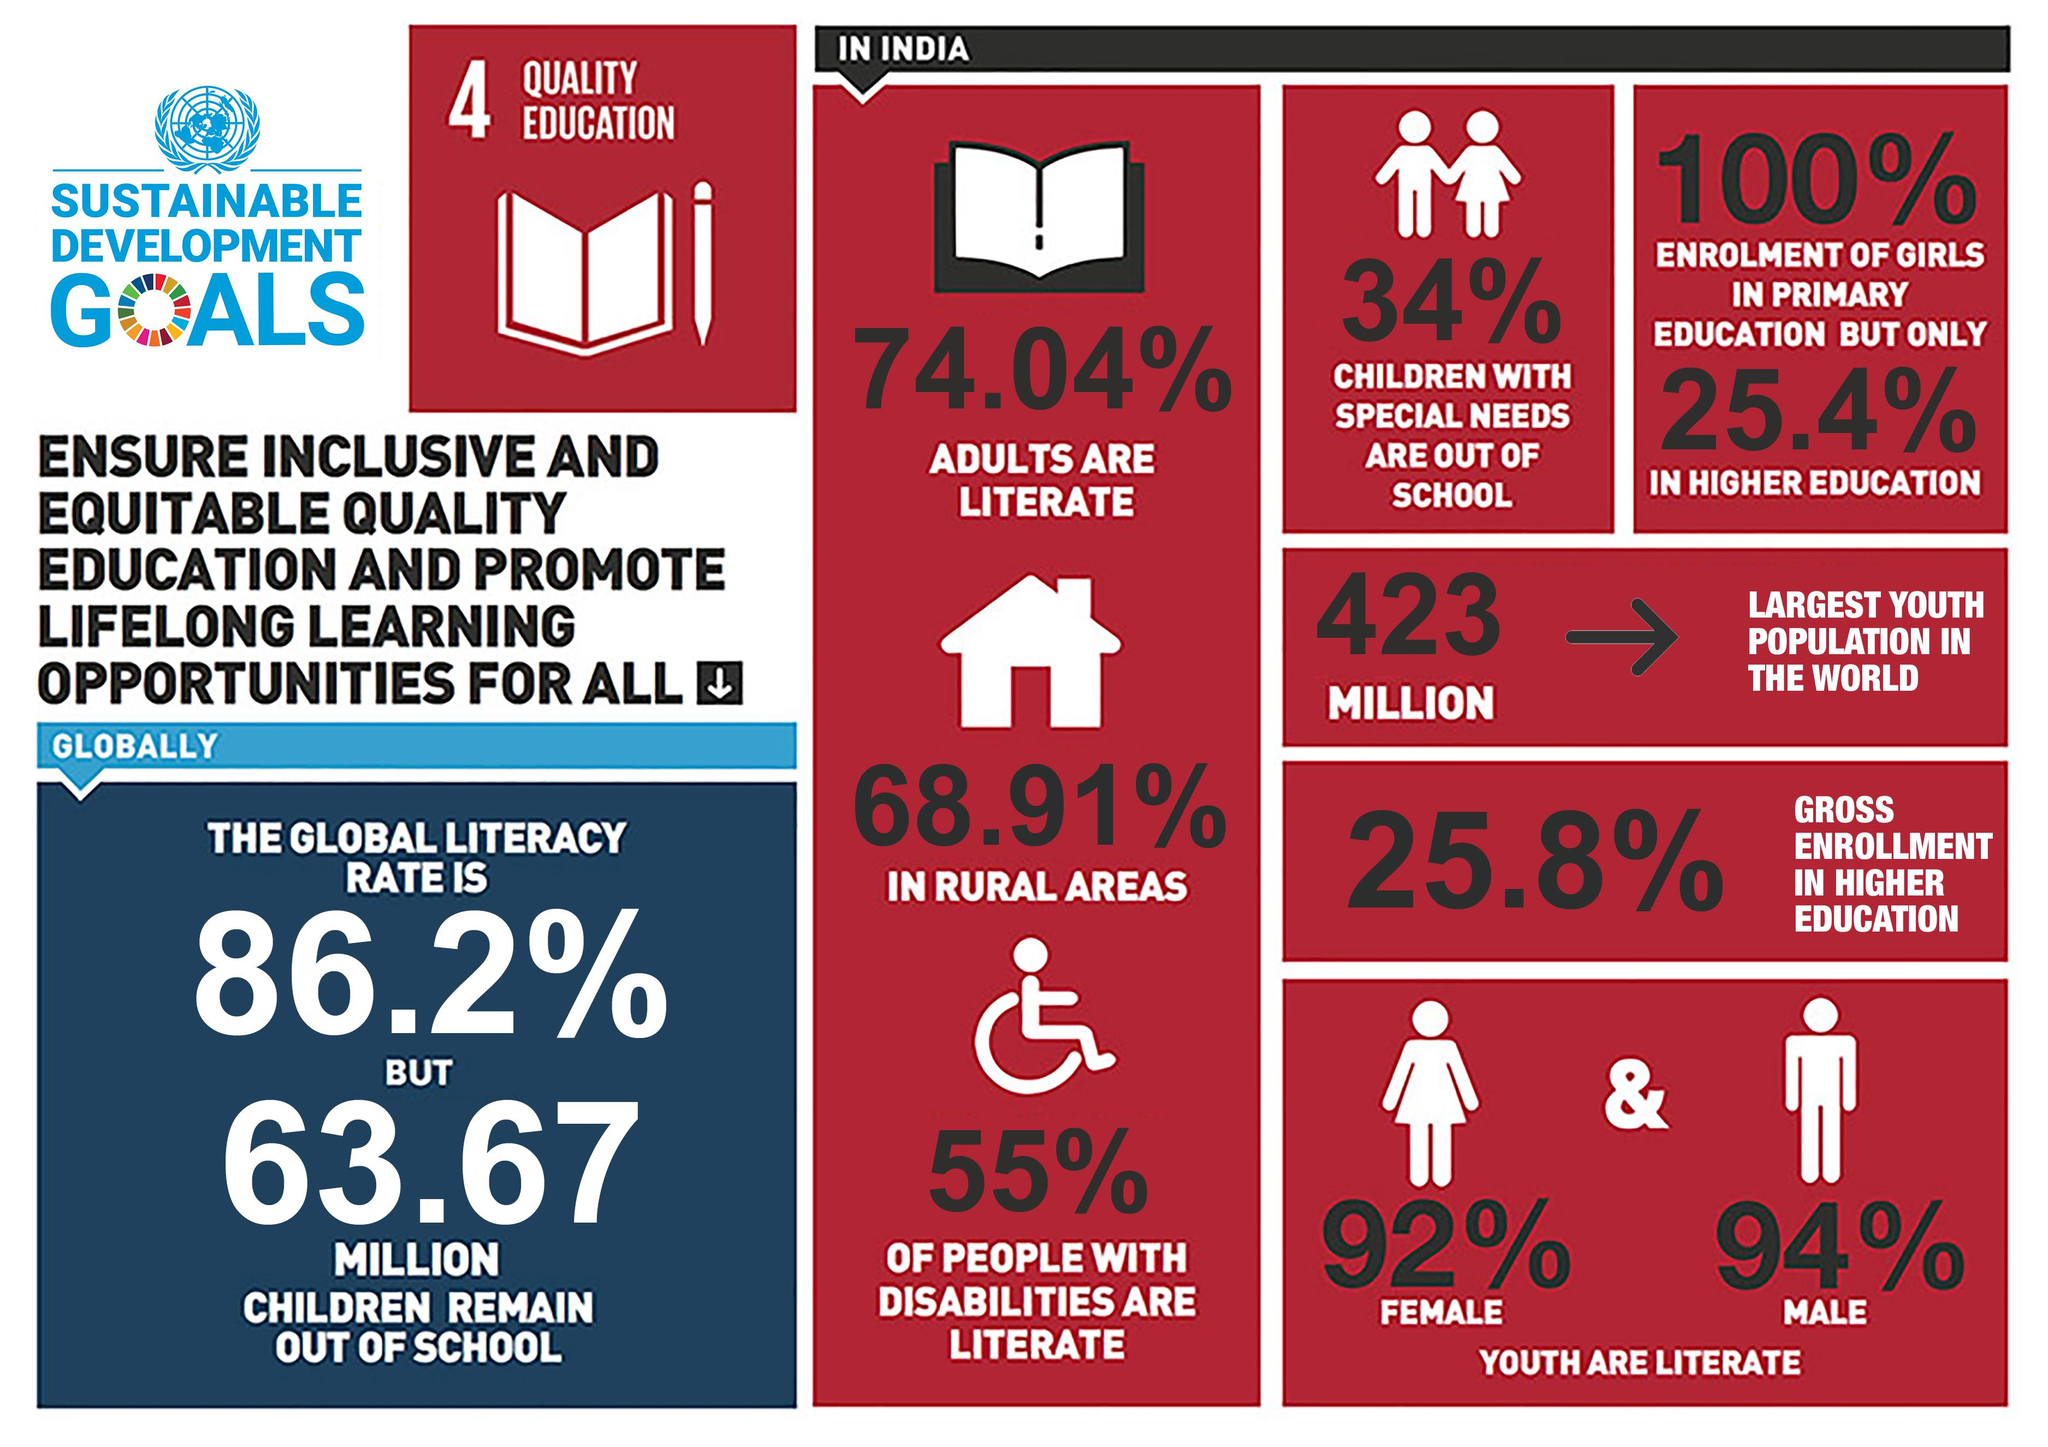Specify some key components in this picture. According to recent data, a staggering 34% of children with special needs in India are out of school, highlighting the urgent need for greater access to education and support for these vulnerable populations. In India, approximately 45% of individuals with disabilities are illiterate. The global population of children who remain out of school is approximately 63.67 MILLION. In India, it is reported that 92% of literate youth are female. According to recent statistics, approximately 25.96% of adults in India are illiterate. 